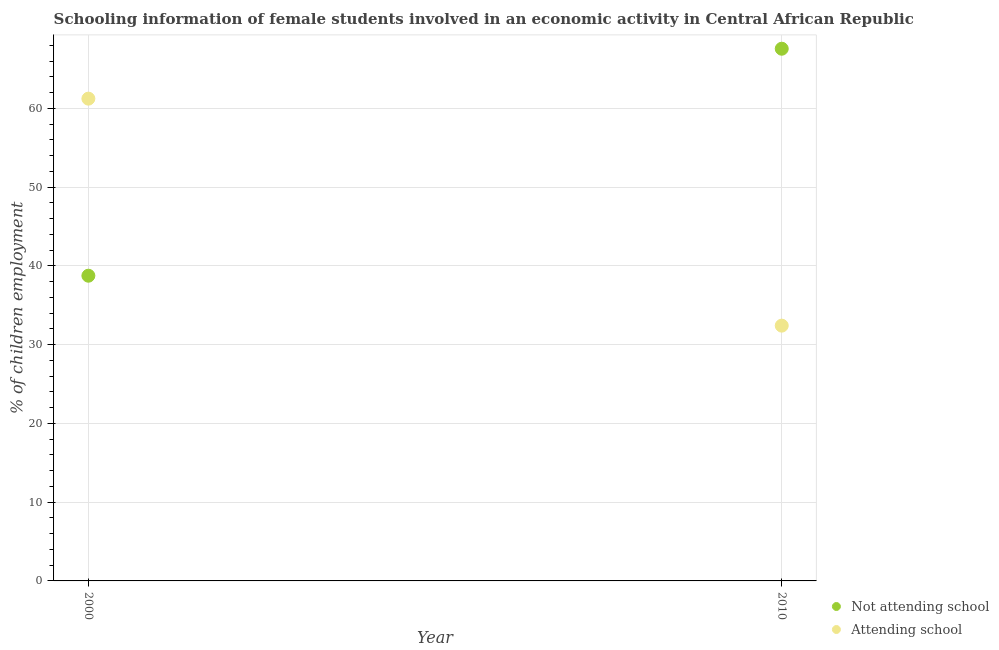How many different coloured dotlines are there?
Your answer should be very brief. 2. Is the number of dotlines equal to the number of legend labels?
Provide a short and direct response. Yes. What is the percentage of employed females who are attending school in 2010?
Provide a succinct answer. 32.42. Across all years, what is the maximum percentage of employed females who are not attending school?
Provide a short and direct response. 67.58. Across all years, what is the minimum percentage of employed females who are not attending school?
Give a very brief answer. 38.76. In which year was the percentage of employed females who are not attending school maximum?
Offer a terse response. 2010. What is the total percentage of employed females who are not attending school in the graph?
Provide a succinct answer. 106.34. What is the difference between the percentage of employed females who are attending school in 2000 and that in 2010?
Ensure brevity in your answer.  28.82. What is the difference between the percentage of employed females who are attending school in 2010 and the percentage of employed females who are not attending school in 2000?
Your answer should be very brief. -6.34. What is the average percentage of employed females who are attending school per year?
Make the answer very short. 46.83. In the year 2000, what is the difference between the percentage of employed females who are not attending school and percentage of employed females who are attending school?
Provide a succinct answer. -22.49. What is the ratio of the percentage of employed females who are not attending school in 2000 to that in 2010?
Ensure brevity in your answer.  0.57. Is the percentage of employed females who are not attending school in 2000 less than that in 2010?
Provide a short and direct response. Yes. In how many years, is the percentage of employed females who are not attending school greater than the average percentage of employed females who are not attending school taken over all years?
Offer a very short reply. 1. How many dotlines are there?
Your answer should be very brief. 2. What is the difference between two consecutive major ticks on the Y-axis?
Offer a very short reply. 10. Are the values on the major ticks of Y-axis written in scientific E-notation?
Offer a very short reply. No. Does the graph contain grids?
Keep it short and to the point. Yes. How are the legend labels stacked?
Provide a short and direct response. Vertical. What is the title of the graph?
Ensure brevity in your answer.  Schooling information of female students involved in an economic activity in Central African Republic. What is the label or title of the Y-axis?
Provide a short and direct response. % of children employment. What is the % of children employment of Not attending school in 2000?
Your answer should be very brief. 38.76. What is the % of children employment of Attending school in 2000?
Your response must be concise. 61.24. What is the % of children employment in Not attending school in 2010?
Give a very brief answer. 67.58. What is the % of children employment in Attending school in 2010?
Offer a terse response. 32.42. Across all years, what is the maximum % of children employment in Not attending school?
Offer a very short reply. 67.58. Across all years, what is the maximum % of children employment of Attending school?
Your response must be concise. 61.24. Across all years, what is the minimum % of children employment in Not attending school?
Keep it short and to the point. 38.76. Across all years, what is the minimum % of children employment in Attending school?
Provide a succinct answer. 32.42. What is the total % of children employment of Not attending school in the graph?
Keep it short and to the point. 106.34. What is the total % of children employment in Attending school in the graph?
Offer a terse response. 93.66. What is the difference between the % of children employment in Not attending school in 2000 and that in 2010?
Give a very brief answer. -28.82. What is the difference between the % of children employment in Attending school in 2000 and that in 2010?
Give a very brief answer. 28.82. What is the difference between the % of children employment in Not attending school in 2000 and the % of children employment in Attending school in 2010?
Provide a succinct answer. 6.34. What is the average % of children employment of Not attending school per year?
Offer a terse response. 53.17. What is the average % of children employment of Attending school per year?
Ensure brevity in your answer.  46.83. In the year 2000, what is the difference between the % of children employment of Not attending school and % of children employment of Attending school?
Provide a succinct answer. -22.49. In the year 2010, what is the difference between the % of children employment in Not attending school and % of children employment in Attending school?
Make the answer very short. 35.16. What is the ratio of the % of children employment in Not attending school in 2000 to that in 2010?
Offer a terse response. 0.57. What is the ratio of the % of children employment of Attending school in 2000 to that in 2010?
Your answer should be compact. 1.89. What is the difference between the highest and the second highest % of children employment in Not attending school?
Provide a succinct answer. 28.82. What is the difference between the highest and the second highest % of children employment in Attending school?
Give a very brief answer. 28.82. What is the difference between the highest and the lowest % of children employment in Not attending school?
Your answer should be compact. 28.82. What is the difference between the highest and the lowest % of children employment in Attending school?
Offer a very short reply. 28.82. 